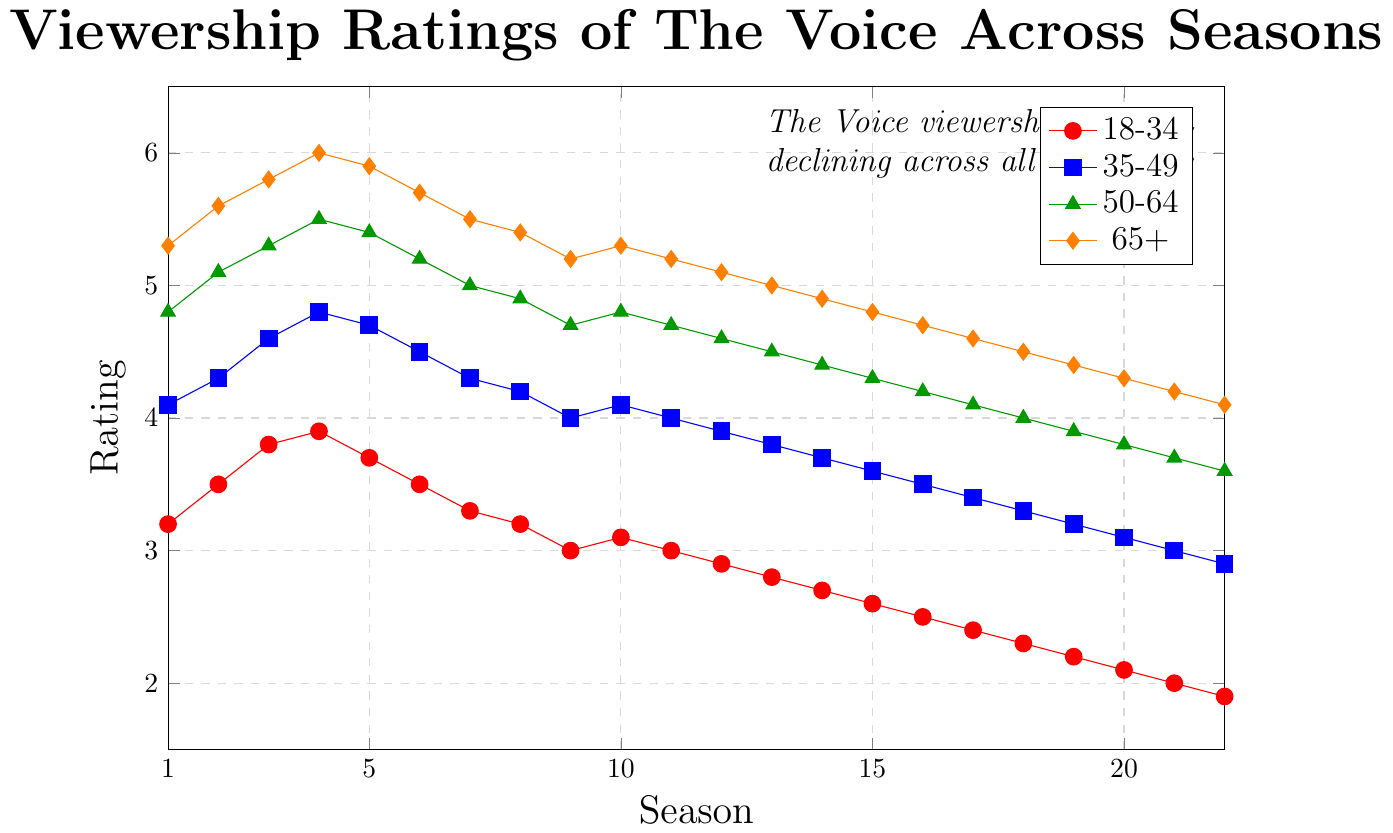Which age group consistently had the highest viewership ratings across all seasons? To determine which age group had the highest viewership ratings, observe the lines in the chart and identify which one is consistently above the others across all seasons. The orange line (65+) is always at the top.
Answer: 65+ What is the difference in viewership ratings between the 18-34 and 65+ age groups in Season 22? For Season 22, the rating for the 18-34 group is 1.9, and for the 65+ group, it's 4.1. Subtract the 18-34 rating from the 65+ rating: 4.1 - 1.9 = 2.2.
Answer: 2.2 In which season did the 50-64 age group reach its peak viewership rating, and what was the rating? To find the peak, look for the highest point on the green line representing the 50-64 age group. It peaks in Season 4 with a rating of 5.5.
Answer: Season 4, 5.5 What is the average viewership rating for the 35-49 age group over the first 5 seasons? Sum the ratings for Seasons 1 to 5: 4.1 + 4.3 + 4.6 + 4.8 + 4.7 = 22.5. Divide by the number of seasons (5): 22.5 / 5 = 4.5.
Answer: 4.5 How much did the 18-34 age group’s viewership rating decrease from Season 1 to Season 22? Subtract the rating in Season 22 (1.9) from the rating in Season 1 (3.2): 3.2 - 1.9 = 1.3.
Answer: 1.3 Which age group showed the smallest decline in viewership ratings between Season 1 and Season 22? Calculate the decline for each group: 
18-34: 3.2 - 1.9 = 1.3
35-49: 4.1 - 2.9 = 1.2 
50-64: 4.8 - 3.6 = 1.2
65+: 5.3 - 4.1 = 1.2
Three groups (35-49, 50-64, 65+) had the same smallest decline of 1.2 points.
Answer: 35-49, 50-64, 65+ Which age group had the most significant drop in viewership across the seasons, and what was the approximate amount? Calculate the difference from Season 1 to Season 22 for each group and identify the largest. The 18-34 age group dropped from 3.2 to 1.9, a decrease of 1.3, the largest drop among all age groups.
Answer: 18-34, 1.3 What is the ratio of the 50-64 age group's viewership rating in Season 10 to the 18-34 age group's rating in the same season? Retrieve the ratings: 50-64 (Season 10) = 4.8, 18-34 (Season 10) = 3.1. Divide the former by the latter: 4.8 / 3.1 ≈ 1.55.
Answer: 1.55 Which seasons had equal viewership ratings for the 18-34 and 35-49 age groups? Check the ratings where both age groups have the same value across the seasons. Both age groups have a rating of 3.0 in Season 11.
Answer: Season 11 How did the average viewership ratings for the 65+ and 18-34 age groups compare across the first 5 seasons? Calculate the averages:
65+: (5.3 + 5.6 + 5.8 + 6.0 + 5.9) / 5 = 5.72
18-34: (3.2 + 3.5 + 3.8 + 3.9 + 3.7) / 5 = 3.62
Compare the averages: 5.72 vs. 3.62.
Answer: 65+ higher by 2.1 